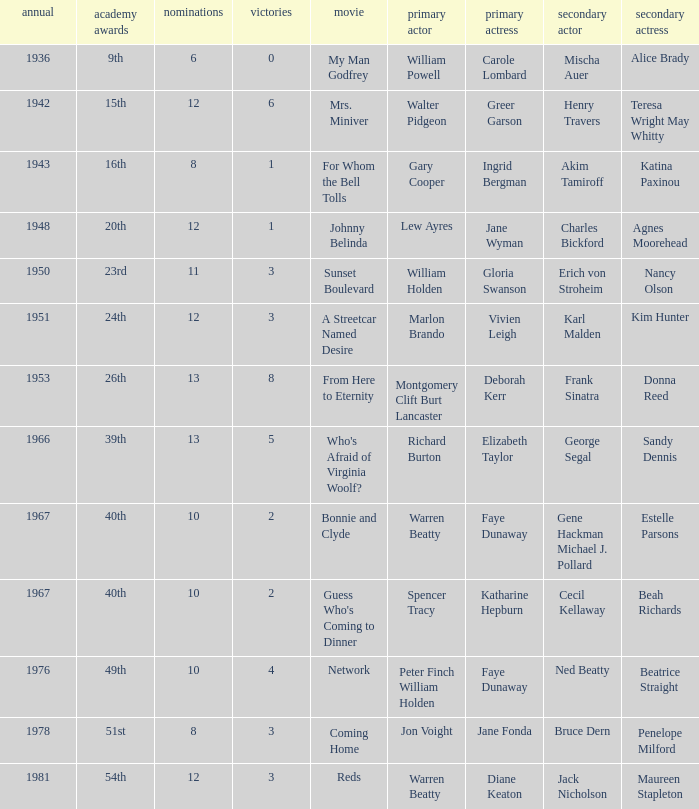Who was the supporting actress in "For Whom the Bell Tolls"? Katina Paxinou. 